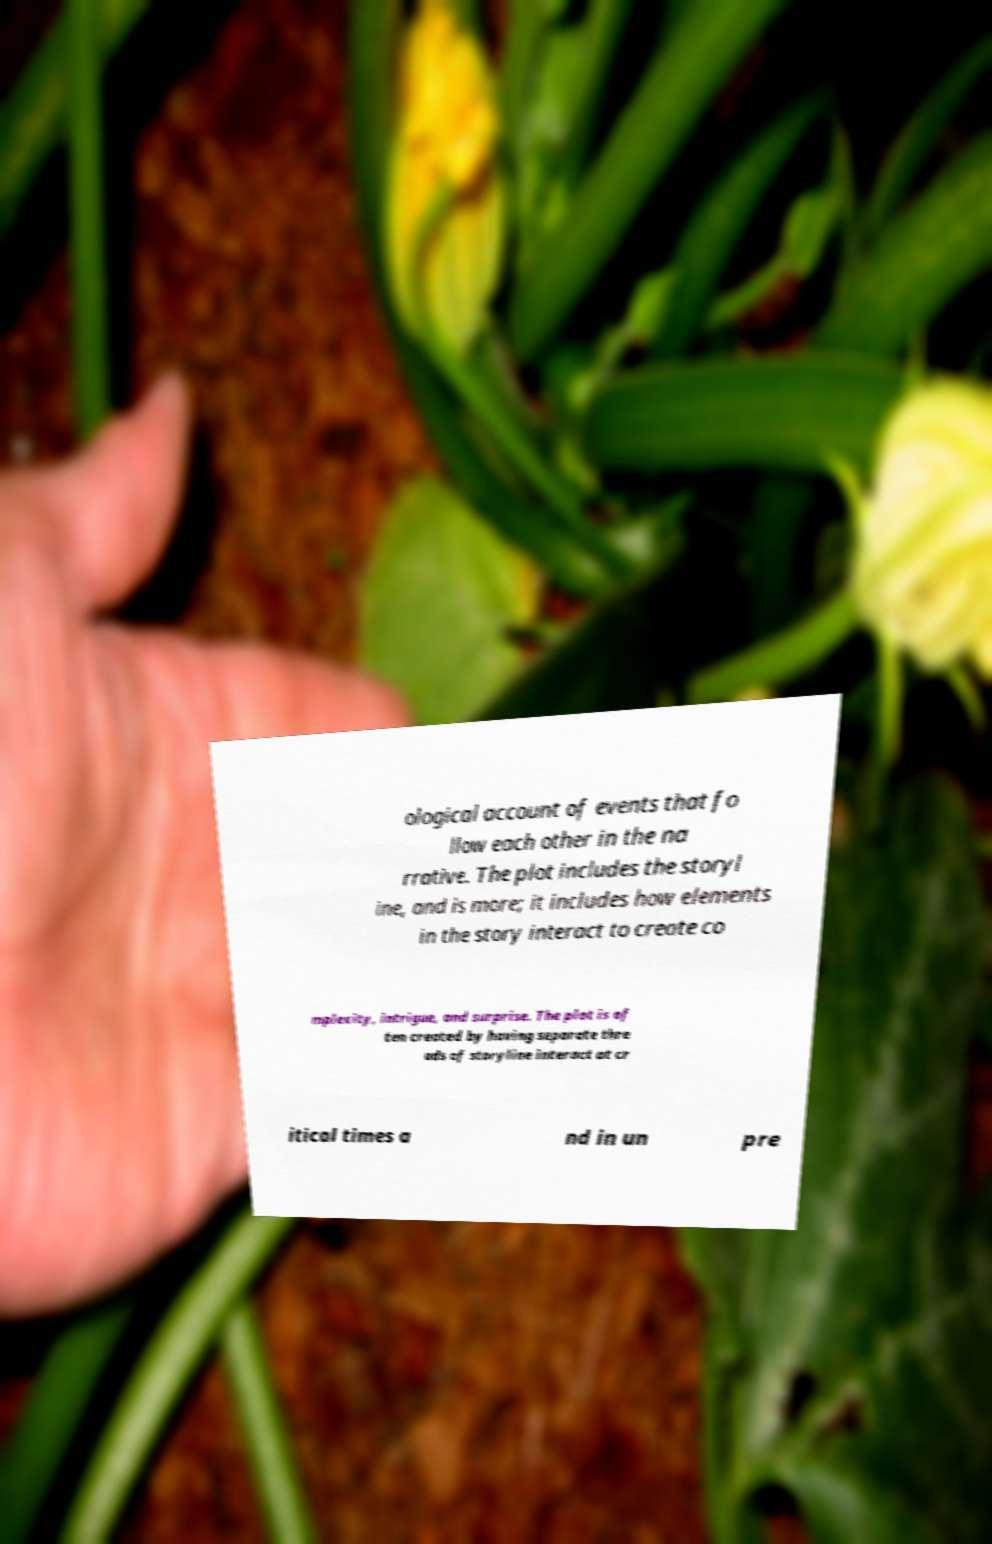I need the written content from this picture converted into text. Can you do that? ological account of events that fo llow each other in the na rrative. The plot includes the storyl ine, and is more; it includes how elements in the story interact to create co mplexity, intrigue, and surprise. The plot is of ten created by having separate thre ads of storyline interact at cr itical times a nd in un pre 